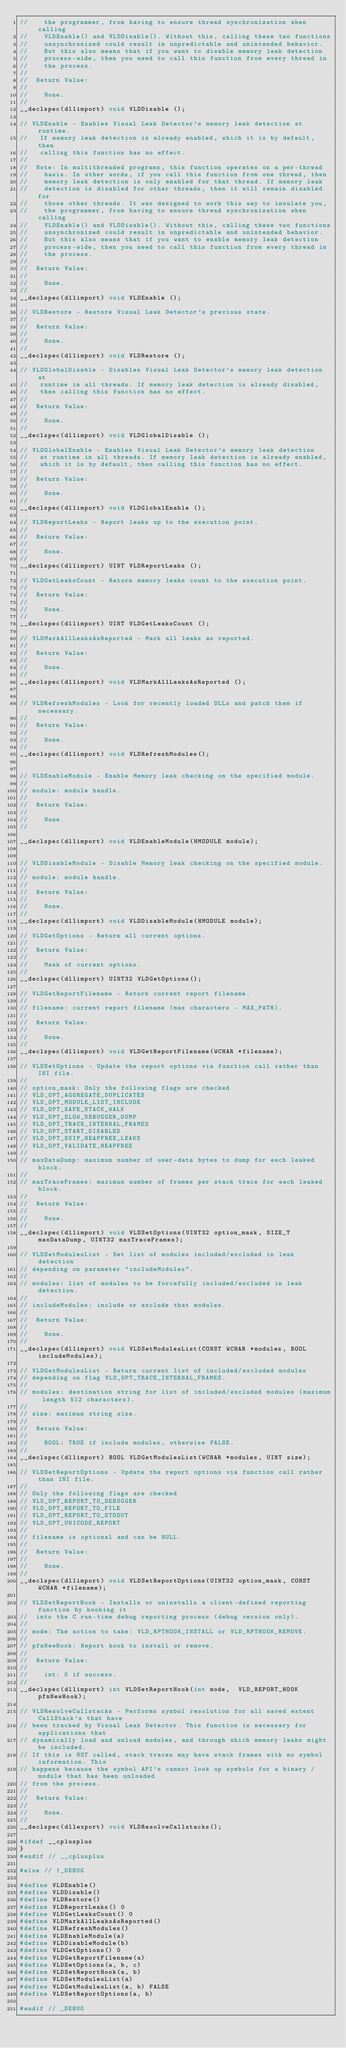<code> <loc_0><loc_0><loc_500><loc_500><_C_>//    the programmer, from having to ensure thread synchronization when calling
//    VLDEnable() and VLDDisable(). Without this, calling these two functions
//    unsynchronized could result in unpredictable and unintended behavior.
//    But this also means that if you want to disable memory leak detection
//    process-wide, then you need to call this function from every thread in
//    the process.
//
//  Return Value:
//
//    None.
//
__declspec(dllimport) void VLDDisable ();

// VLDEnable - Enables Visual Leak Detector's memory leak detection at runtime.
//   If memory leak detection is already enabled, which it is by default, then
//   calling this function has no effect.
//
//  Note: In multithreaded programs, this function operates on a per-thread
//    basis. In other words, if you call this function from one thread, then
//    memory leak detection is only enabled for that thread. If memory leak
//    detection is disabled for other threads, then it will remain disabled for
//    those other threads. It was designed to work this way to insulate you,
//    the programmer, from having to ensure thread synchronization when calling
//    VLDEnable() and VLDDisable(). Without this, calling these two functions
//    unsynchronized could result in unpredictable and unintended behavior.
//    But this also means that if you want to enable memory leak detection
//    process-wide, then you need to call this function from every thread in
//    the process.
//
//  Return Value:
//
//    None.
//
__declspec(dllimport) void VLDEnable ();

// VLDRestore - Restore Visual Leak Detector's previous state.
//
//  Return Value:
//
//    None.
//
__declspec(dllimport) void VLDRestore ();

// VLDGlobalDisable - Disables Visual Leak Detector's memory leak detection at
//   runtime in all threads. If memory leak detection is already disabled, 
//   then calling this function has no effect.
//
//  Return Value:
//
//    None.
//
__declspec(dllimport) void VLDGlobalDisable ();

// VLDGlobalEnable - Enables Visual Leak Detector's memory leak detection 
//   at runtime in all threads. If memory leak detection is already enabled, 
//   which it is by default, then calling this function has no effect.
//
//  Return Value:
//
//    None.
//
__declspec(dllimport) void VLDGlobalEnable ();

// VLDReportLeaks - Report leaks up to the execution point.
//
//  Return Value:
//
//    None.
//
__declspec(dllimport) UINT VLDReportLeaks ();

// VLDGetLeaksCount - Return memory leaks count to the execution point.
//
//  Return Value:
//
//    None.
//
__declspec(dllimport) UINT VLDGetLeaksCount ();

// VLDMarkAllLeaksAsReported - Mark all leaks as reported.
//
//  Return Value:
//
//    None.
//
__declspec(dllimport) void VLDMarkAllLeaksAsReported ();


// VLDRefreshModules - Look for recently loaded DLLs and patch them if necessary.
//
//  Return Value:
//
//    None.
//
__declspec(dllimport) void VLDRefreshModules();


// VLDEnableModule - Enable Memory leak checking on the specified module.
//
// module: module handle.
//
//  Return Value:
//
//    None.
//

__declspec(dllimport) void VLDEnableModule(HMODULE module);


// VLDDisableModule - Disable Memory leak checking on the specified module.
//
// module: module handle.
//
//  Return Value:
//
//    None.
//
__declspec(dllimport) void VLDDisableModule(HMODULE module);

// VLDGetOptions - Return all current options.
//
//  Return Value:
//
//    Mask of current options.
//
__declspec(dllimport) UINT32 VLDGetOptions();

// VLDGetReportFilename - Return current report filename.
//
// filename: current report filename (max characters - MAX_PATH).
//
//  Return Value:
//
//    None.
//
__declspec(dllimport) void VLDGetReportFilename(WCHAR *filename);

// VLDSetOptions - Update the report options via function call rather than INI file.
//
// option_mask: Only the following flags are checked
// VLD_OPT_AGGREGATE_DUPLICATES
// VLD_OPT_MODULE_LIST_INCLUDE
// VLD_OPT_SAFE_STACK_WALK
// VLD_OPT_SLOW_DEBUGGER_DUMP
// VLD_OPT_TRACE_INTERNAL_FRAMES
// VLD_OPT_START_DISABLED
// VLD_OPT_SKIP_HEAPFREE_LEAKS
// VLD_OPT_VALIDATE_HEAPFREE
//
// maxDataDump: maximum number of user-data bytes to dump for each leaked block.
//
// maxTraceFrames: maximum number of frames per stack trace for each leaked block.
//
//  Return Value:
//
//    None.
//
__declspec(dllimport) void VLDSetOptions(UINT32 option_mask, SIZE_T maxDataDump, UINT32 maxTraceFrames);

// VLDSetModulesList - Set list of modules included/excluded in leak detection
// depending on parameter "includeModules".
//
// modules: list of modules to be forcefully included/excluded in leak detection.
//
// includeModules: include or exclude that modules.
//
//  Return Value:
//
//    None.
//
__declspec(dllimport) void VLDSetModulesList(CONST WCHAR *modules, BOOL includeModules);

// VLDGetModulesList - Return current list of included/excluded modules
// depending on flag VLD_OPT_TRACE_INTERNAL_FRAMES.
//
// modules: destination string for list of included/excluded modules (maximum length 512 characters).
//
// size: maximum string size.
//
//  Return Value:
//
//    BOOL: TRUE if include modules, otherwise FALSE.
//
__declspec(dllimport) BOOL VLDGetModulesList(WCHAR *modules, UINT size);

// VLDSetReportOptions - Update the report options via function call rather than INI file.
//
// Only the following flags are checked
// VLD_OPT_REPORT_TO_DEBUGGER
// VLD_OPT_REPORT_TO_FILE
// VLD_OPT_REPORT_TO_STDOUT
// VLD_OPT_UNICODE_REPORT
//
// filename is optional and can be NULL.
//
//  Return Value:
//
//    None.
//
__declspec(dllimport) void VLDSetReportOptions(UINT32 option_mask, CONST WCHAR *filename);

// VLDSetReportHook - Installs or uninstalls a client-defined reporting function by hooking it 
//  into the C run-time debug reporting process (debug version only).
//
// mode: The action to take: VLD_RPTHOOK_INSTALL or VLD_RPTHOOK_REMOVE.
//
// pfnNewHook: Report hook to install or remove.
//
//  Return Value:
//
//    int: 0 if success.
//
__declspec(dllimport) int VLDSetReportHook(int mode,  VLD_REPORT_HOOK pfnNewHook);

// VLDResolveCallstacks - Performs symbol resolution for all saved extent CallStack's that have
// been tracked by Visual Leak Detector. This function is necessary for applications that 
// dynamically load and unload modules, and through which memory leaks might be included.
// If this is NOT called, stack traces may have stack frames with no symbol information. This 
// happens because the symbol API's cannot look up symbols for a binary / module that has been unloaded
// from the process.
//
//  Return Value:
//
//    None.
//
__declspec(dllexport) void VLDResolveCallstacks();

#ifdef __cplusplus
}
#endif // __cplusplus

#else // !_DEBUG

#define VLDEnable()
#define VLDDisable()
#define VLDRestore()
#define VLDReportLeaks() 0
#define VLDGetLeaksCount() 0
#define VLDMarkAllLeaksAsReported()
#define VLDRefreshModules()
#define VLDEnableModule(a)
#define VLDDisableModule(b)
#define VLDGetOptions() 0
#define VLDGetReportFilename(a)
#define VLDSetOptions(a, b, c)
#define VLDSetReportHook(a, b)
#define VLDSetModulesList(a)
#define VLDGetModulesList(a, b) FALSE
#define VLDSetReportOptions(a, b)

#endif // _DEBUG
</code> 